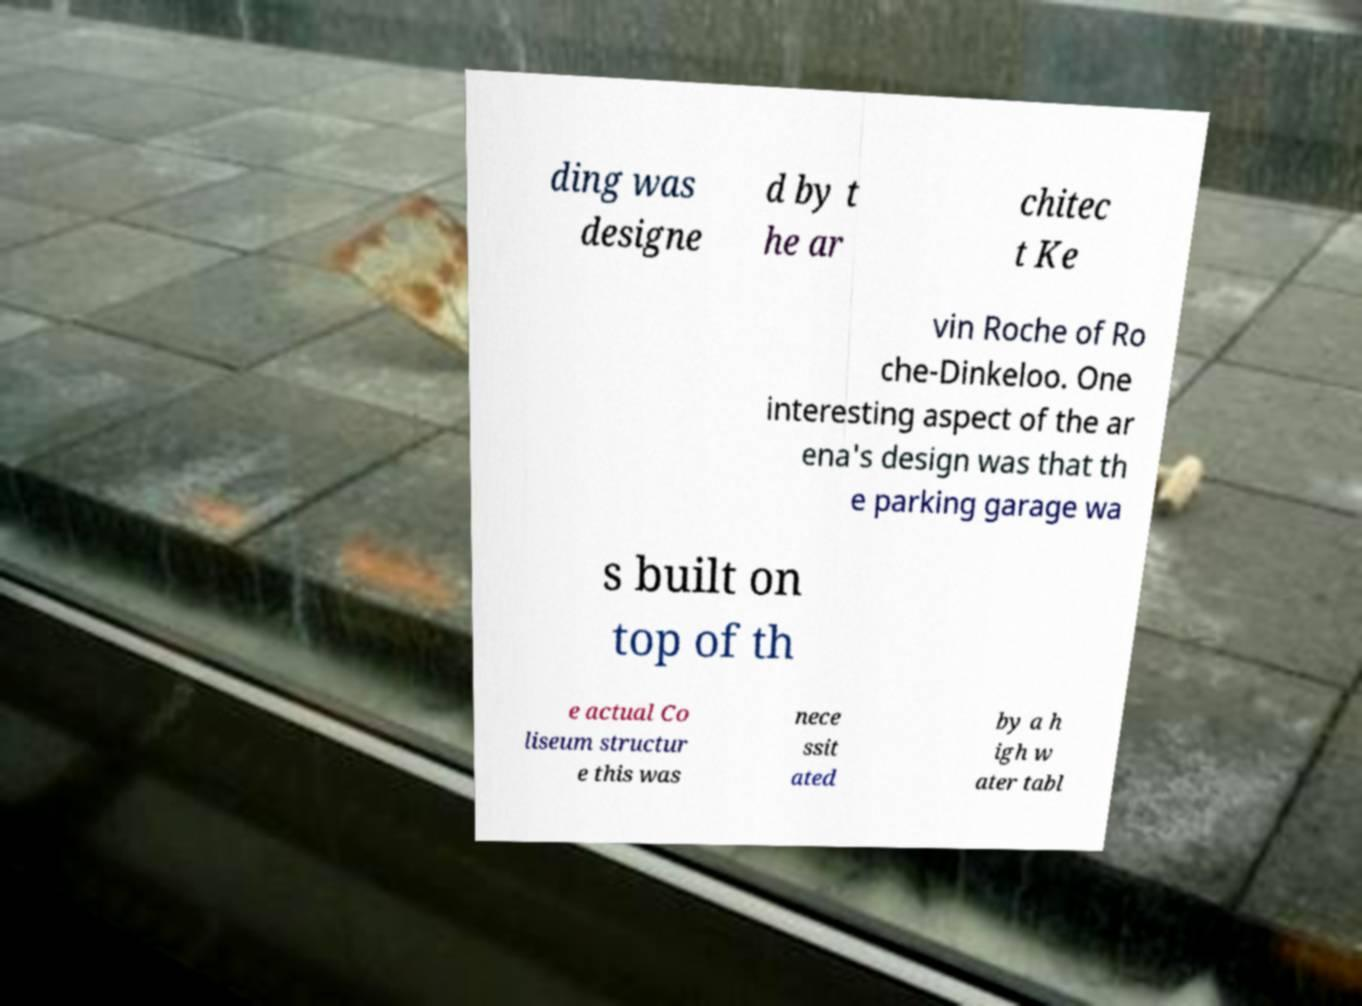Could you extract and type out the text from this image? ding was designe d by t he ar chitec t Ke vin Roche of Ro che-Dinkeloo. One interesting aspect of the ar ena's design was that th e parking garage wa s built on top of th e actual Co liseum structur e this was nece ssit ated by a h igh w ater tabl 